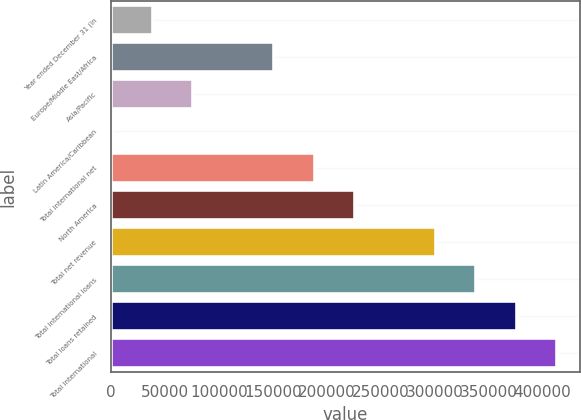Convert chart to OTSL. <chart><loc_0><loc_0><loc_500><loc_500><bar_chart><fcel>Year ended December 31 (in<fcel>Europe/Middle East/Africa<fcel>Asia/Pacific<fcel>Latin America/Caribbean<fcel>Total international net<fcel>North America<fcel>Total net revenue<fcel>Total international loans<fcel>Total loans retained<fcel>Total international<nl><fcel>38731.2<fcel>151250<fcel>76237.4<fcel>1225<fcel>188756<fcel>226262<fcel>301275<fcel>338781<fcel>376287<fcel>413793<nl></chart> 